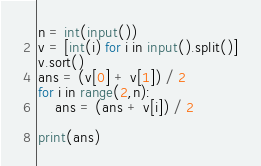Convert code to text. <code><loc_0><loc_0><loc_500><loc_500><_Python_>n = int(input())
v = [int(i) for i in input().split()]
v.sort()
ans = (v[0] + v[1]) / 2
for i in range(2,n):
    ans = (ans + v[i]) / 2

print(ans)</code> 